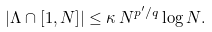Convert formula to latex. <formula><loc_0><loc_0><loc_500><loc_500>| \Lambda \cap [ 1 , N ] | \leq \kappa \, N ^ { p ^ { \prime } / q } \log N .</formula> 